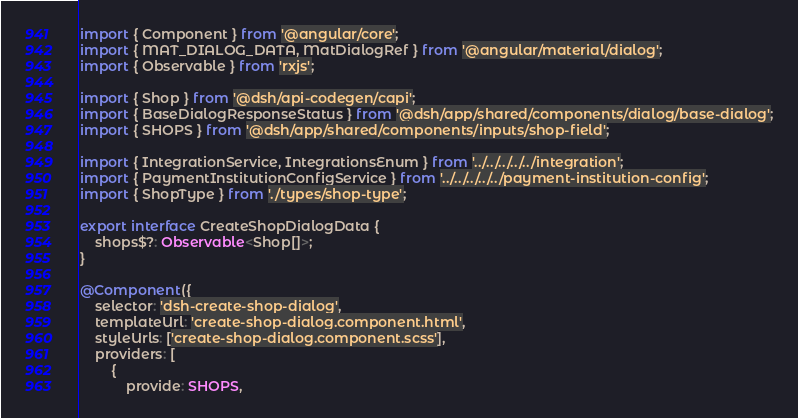<code> <loc_0><loc_0><loc_500><loc_500><_TypeScript_>import { Component } from '@angular/core';
import { MAT_DIALOG_DATA, MatDialogRef } from '@angular/material/dialog';
import { Observable } from 'rxjs';

import { Shop } from '@dsh/api-codegen/capi';
import { BaseDialogResponseStatus } from '@dsh/app/shared/components/dialog/base-dialog';
import { SHOPS } from '@dsh/app/shared/components/inputs/shop-field';

import { IntegrationService, IntegrationsEnum } from '../../../../../integration';
import { PaymentInstitutionConfigService } from '../../../../../payment-institution-config';
import { ShopType } from './types/shop-type';

export interface CreateShopDialogData {
    shops$?: Observable<Shop[]>;
}

@Component({
    selector: 'dsh-create-shop-dialog',
    templateUrl: 'create-shop-dialog.component.html',
    styleUrls: ['create-shop-dialog.component.scss'],
    providers: [
        {
            provide: SHOPS,</code> 